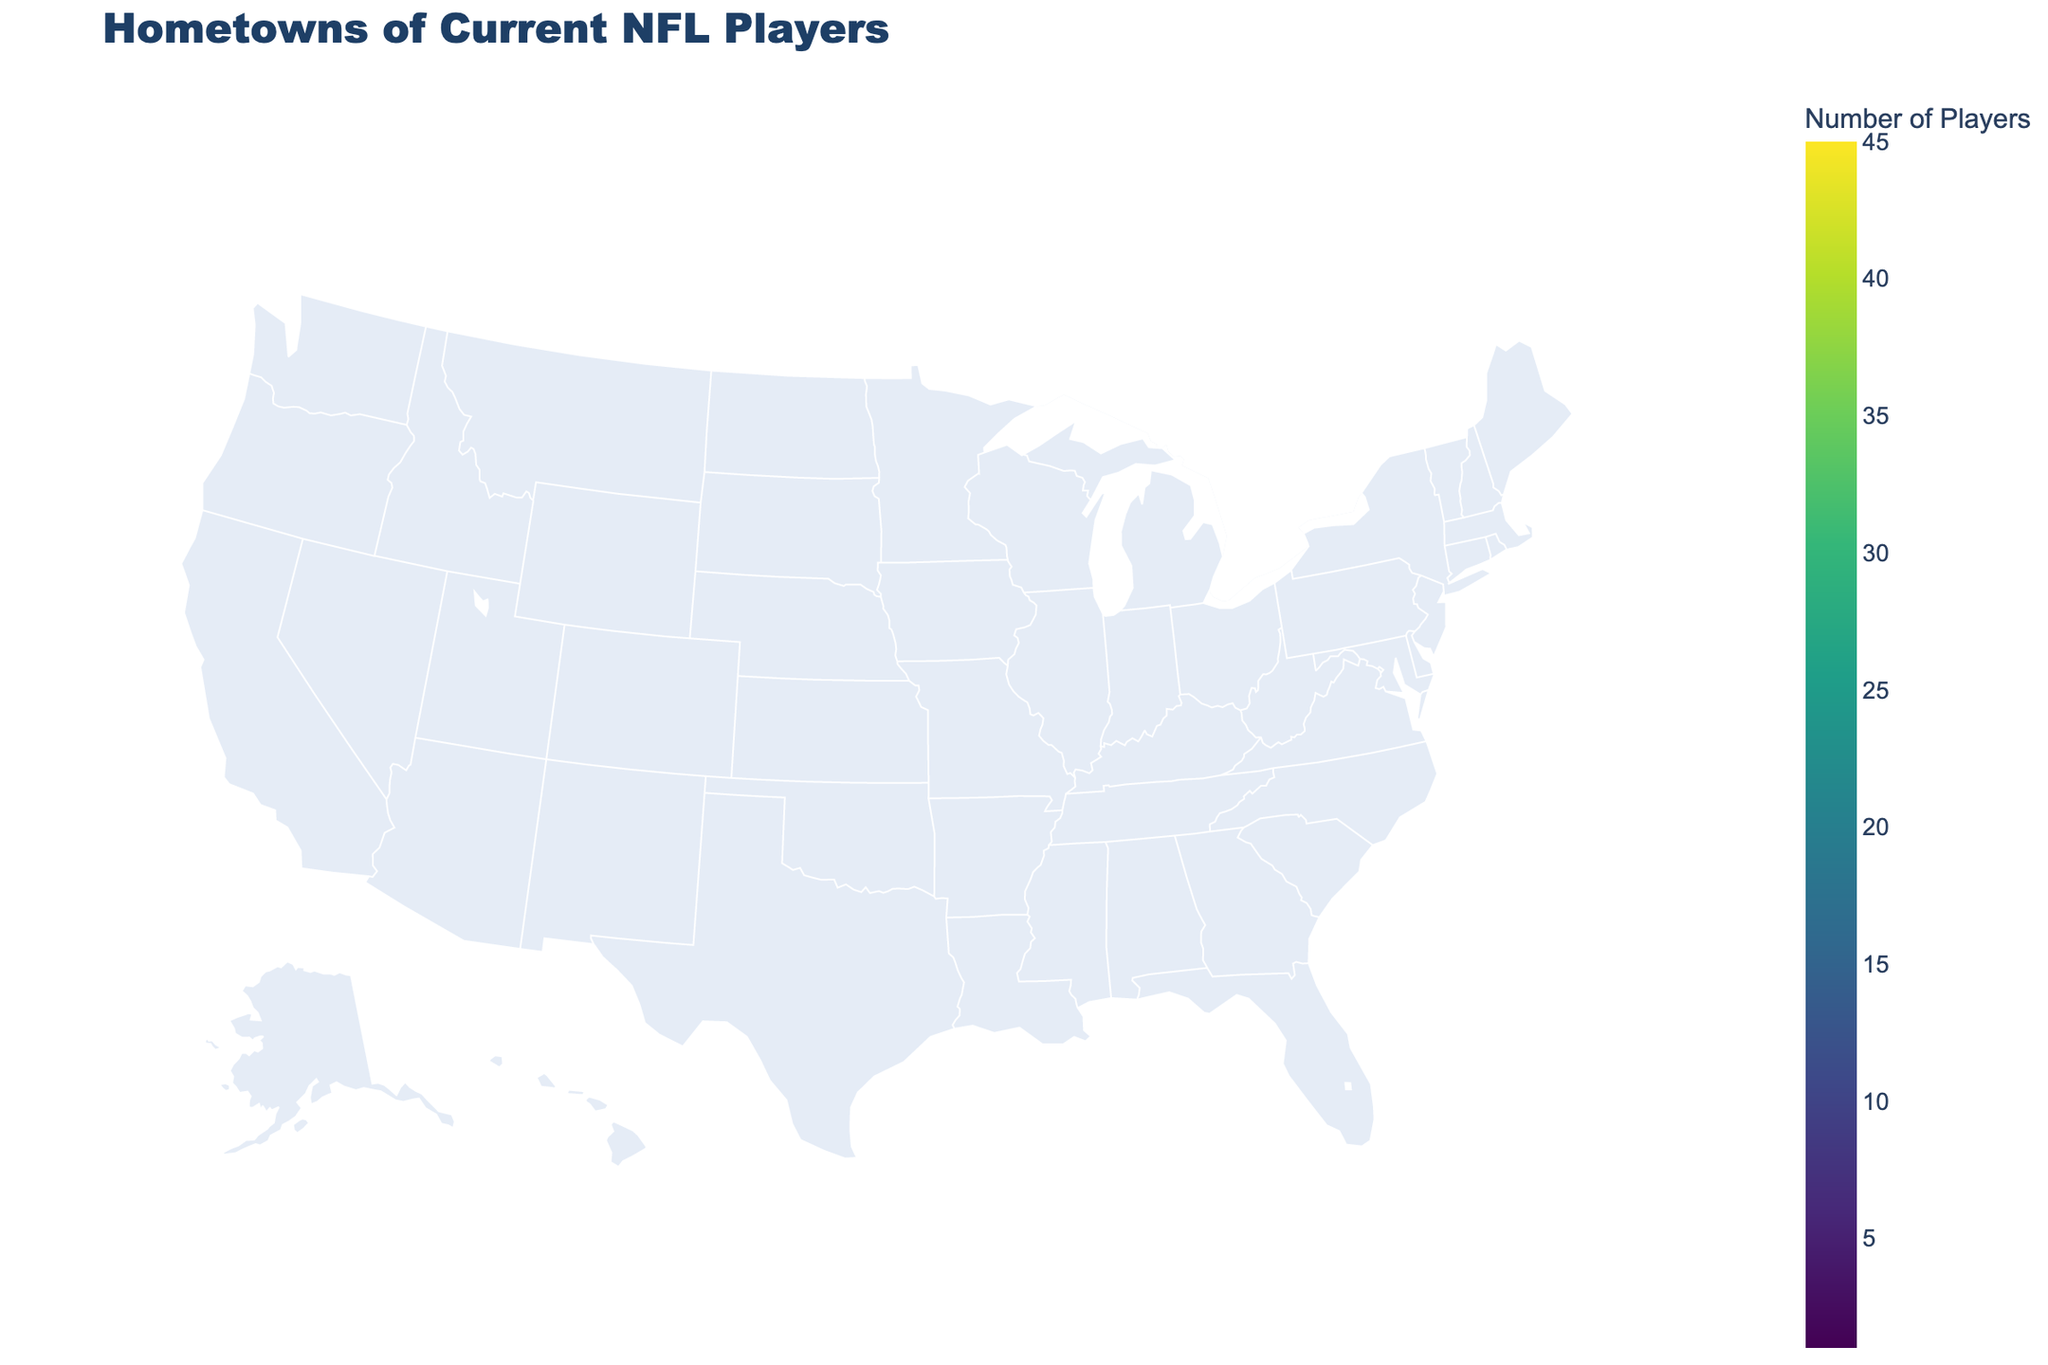What region has the highest number of NFL players' hometowns? The South has the highest number of NFL players' hometowns. This can be seen by observing the states such as Texas, Florida, Georgia, and Alabama which are all located in the South region and have high counts.
Answer: South Which state has the highest number of NFL players and how many? Texas has the highest number of NFL players with a count of 45. This is evident from the map where Texas shows the greatest concentration of players in terms of count.
Answer: Texas, 45 How many states have 10 or more NFL players? To find this, count the states with a 'Count' of 10 or greater. These states are Texas, Florida, California, Georgia, Ohio, Pennsylvania, Alabama, Louisiana, North Carolina, Michigan, Illinois, New Jersey, Virginia, Tennessee, and South Carolina, making it a total of 15 states.
Answer: 15 What is the combined number of NFL players from California and Pennsylvania? Add the number of players from California (38) and Pennsylvania (25). 38 + 25 gives us the combined total of 63.
Answer: 63 Which region has more states with 15 or more NFL players, Midwest or South? We first identify the states in each region with 15 or more players. 
South: Texas (45), Florida (42), Georgia (35), Alabama (22), Louisiana (20), North Carolina (18) 
Midwest: Ohio (28), Michigan (17), Illinois (15)
The South has 6 states compared to the Midwest's 3 states, indicating the South has more states with 15 or more NFL players.
Answer: South What is the average number of NFL players from states in the West region? The states in the West region are California (38), Washington (7), Arizona (5), Oregon (3), and Colorado (2). To find the average: 
(38 + 7 + 5 + 3 + 2) / 5 = 55 / 5 = 11.
Answer: 11 Which state in the Northeast region has the fewest NFL players and how many are there? Look under the Northeast region: Pennsylvania (25), New Jersey (14), Maryland (8), Massachusetts (4), Connecticut (2). Connecticut has the fewest NFL players with a count of 2.
Answer: Connecticut, 2 What is the total number of NFL players from states in the Northeast region? Add the number of players from Pennsylvania (25), New Jersey (14), Maryland (8), Massachusetts (4), and Connecticut (2). 25 + 14 + 8 + 4 + 2 equals 53.
Answer: 53 How does the count of NFL players in Illinois compare to that in Virginia? Illinois has 15 NFL players and Virginia has 13 NFL players. Comparatively, Illinois has 2 more players than Virginia.
Answer: Illinois has 2 more players than Virginia 